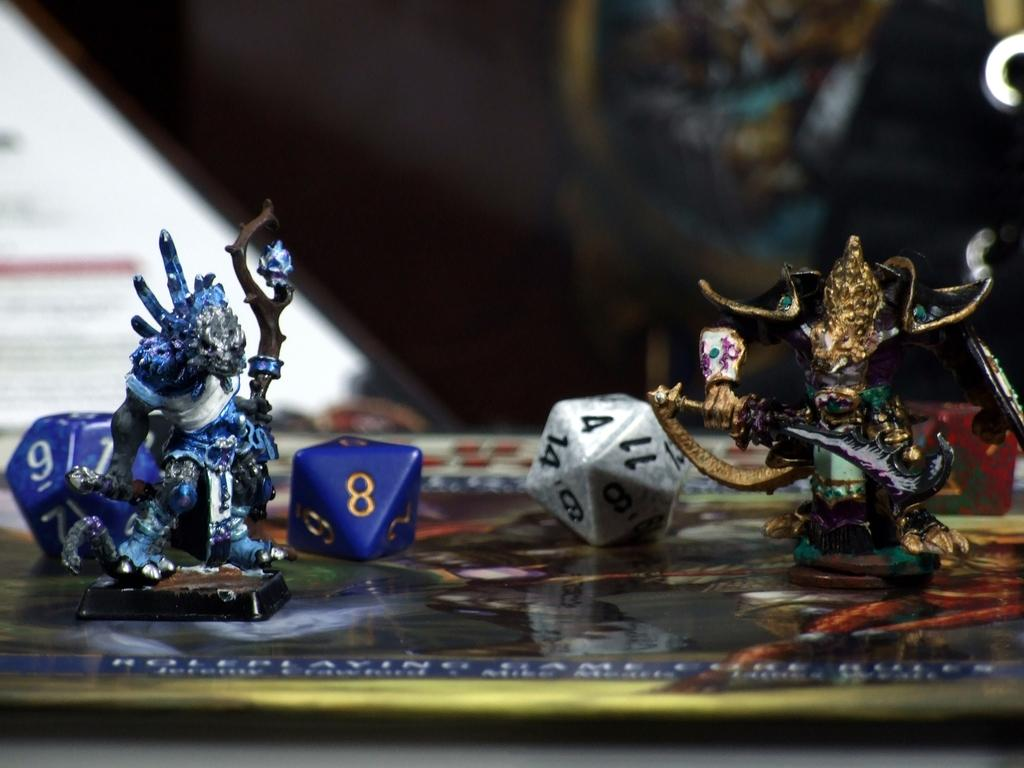What is located in the center of the image? There are toys in the center of the image. What is at the bottom of the image? There is a plate at the bottom of the image. Can you describe what is visible in the background of the image? There are objects visible in the background of the image. Where is the brush located in the image? There is no brush present in the image. Can you see any clover growing in the image? There is no clover visible in the image. 